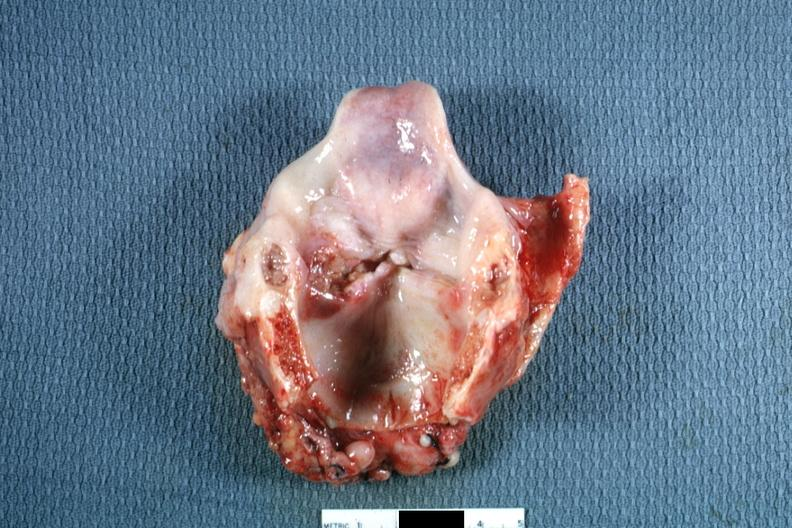what is ulcerative lesion left?
Answer the question using a single word or phrase. True cord quite good 